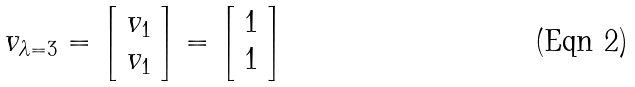Convert formula to latex. <formula><loc_0><loc_0><loc_500><loc_500>v _ { \lambda = 3 } = { \left [ \begin{array} { l } { v _ { 1 } } \\ { v _ { 1 } } \end{array} \right ] } = { \left [ \begin{array} { l } { 1 } \\ { 1 } \end{array} \right ] }</formula> 